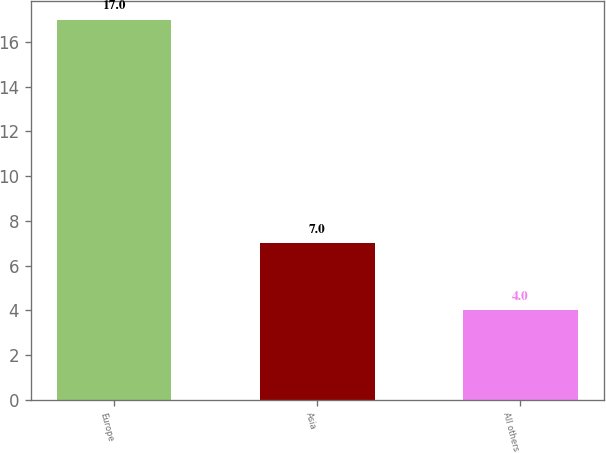<chart> <loc_0><loc_0><loc_500><loc_500><bar_chart><fcel>Europe<fcel>Asia<fcel>All others<nl><fcel>17<fcel>7<fcel>4<nl></chart> 